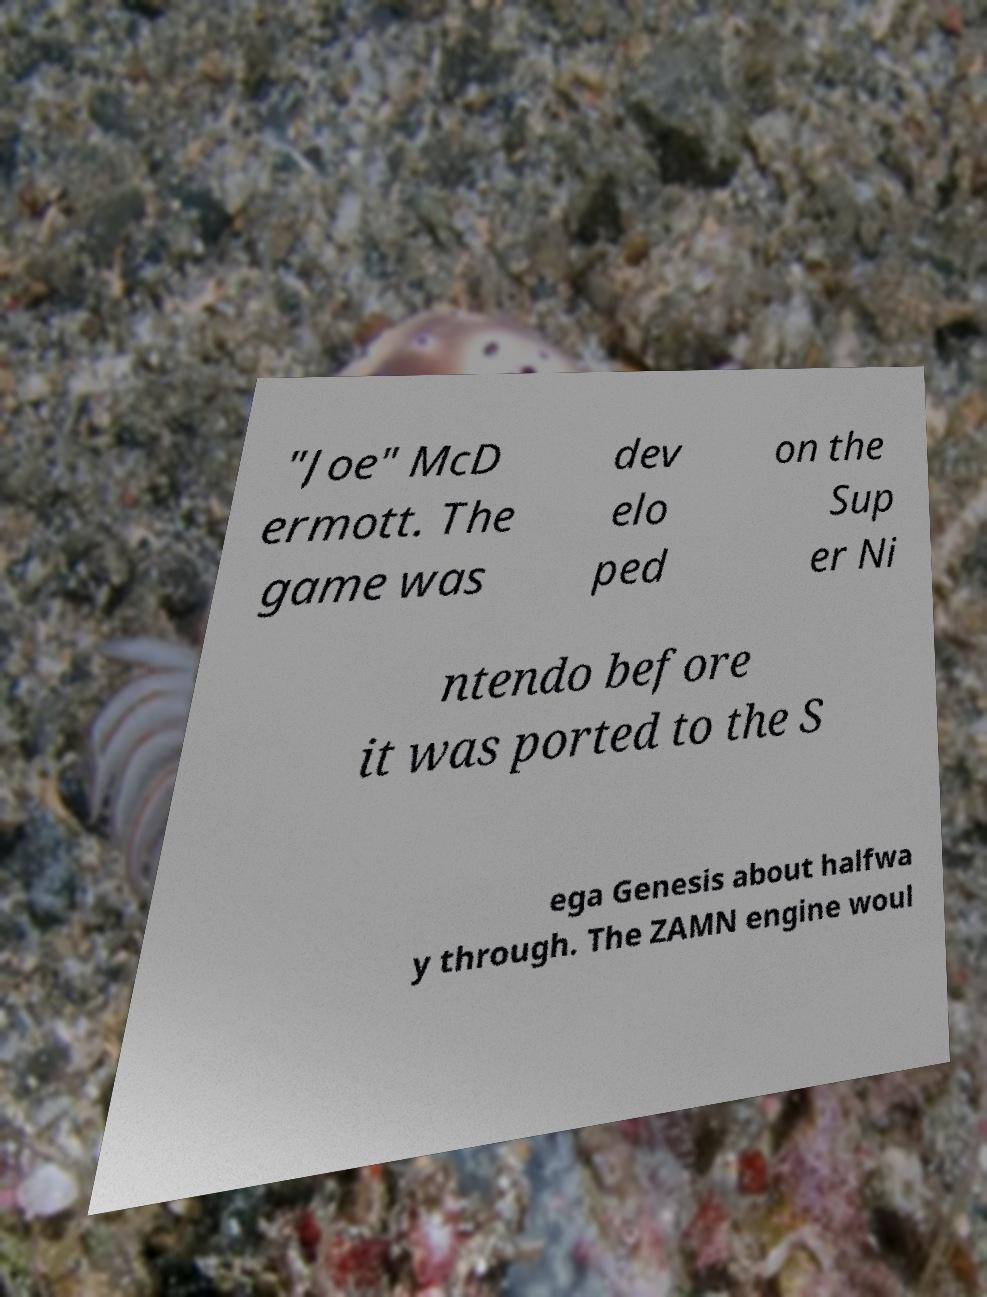Can you read and provide the text displayed in the image?This photo seems to have some interesting text. Can you extract and type it out for me? "Joe" McD ermott. The game was dev elo ped on the Sup er Ni ntendo before it was ported to the S ega Genesis about halfwa y through. The ZAMN engine woul 